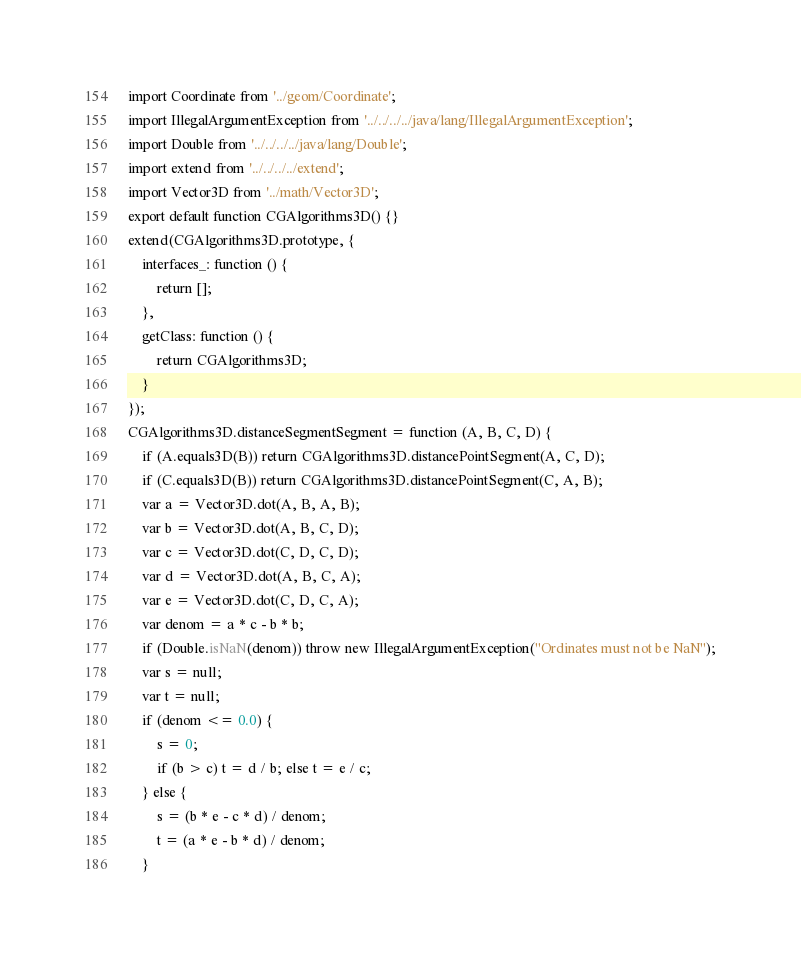Convert code to text. <code><loc_0><loc_0><loc_500><loc_500><_JavaScript_>import Coordinate from '../geom/Coordinate';
import IllegalArgumentException from '../../../../java/lang/IllegalArgumentException';
import Double from '../../../../java/lang/Double';
import extend from '../../../../extend';
import Vector3D from '../math/Vector3D';
export default function CGAlgorithms3D() {}
extend(CGAlgorithms3D.prototype, {
	interfaces_: function () {
		return [];
	},
	getClass: function () {
		return CGAlgorithms3D;
	}
});
CGAlgorithms3D.distanceSegmentSegment = function (A, B, C, D) {
	if (A.equals3D(B)) return CGAlgorithms3D.distancePointSegment(A, C, D);
	if (C.equals3D(B)) return CGAlgorithms3D.distancePointSegment(C, A, B);
	var a = Vector3D.dot(A, B, A, B);
	var b = Vector3D.dot(A, B, C, D);
	var c = Vector3D.dot(C, D, C, D);
	var d = Vector3D.dot(A, B, C, A);
	var e = Vector3D.dot(C, D, C, A);
	var denom = a * c - b * b;
	if (Double.isNaN(denom)) throw new IllegalArgumentException("Ordinates must not be NaN");
	var s = null;
	var t = null;
	if (denom <= 0.0) {
		s = 0;
		if (b > c) t = d / b; else t = e / c;
	} else {
		s = (b * e - c * d) / denom;
		t = (a * e - b * d) / denom;
	}</code> 